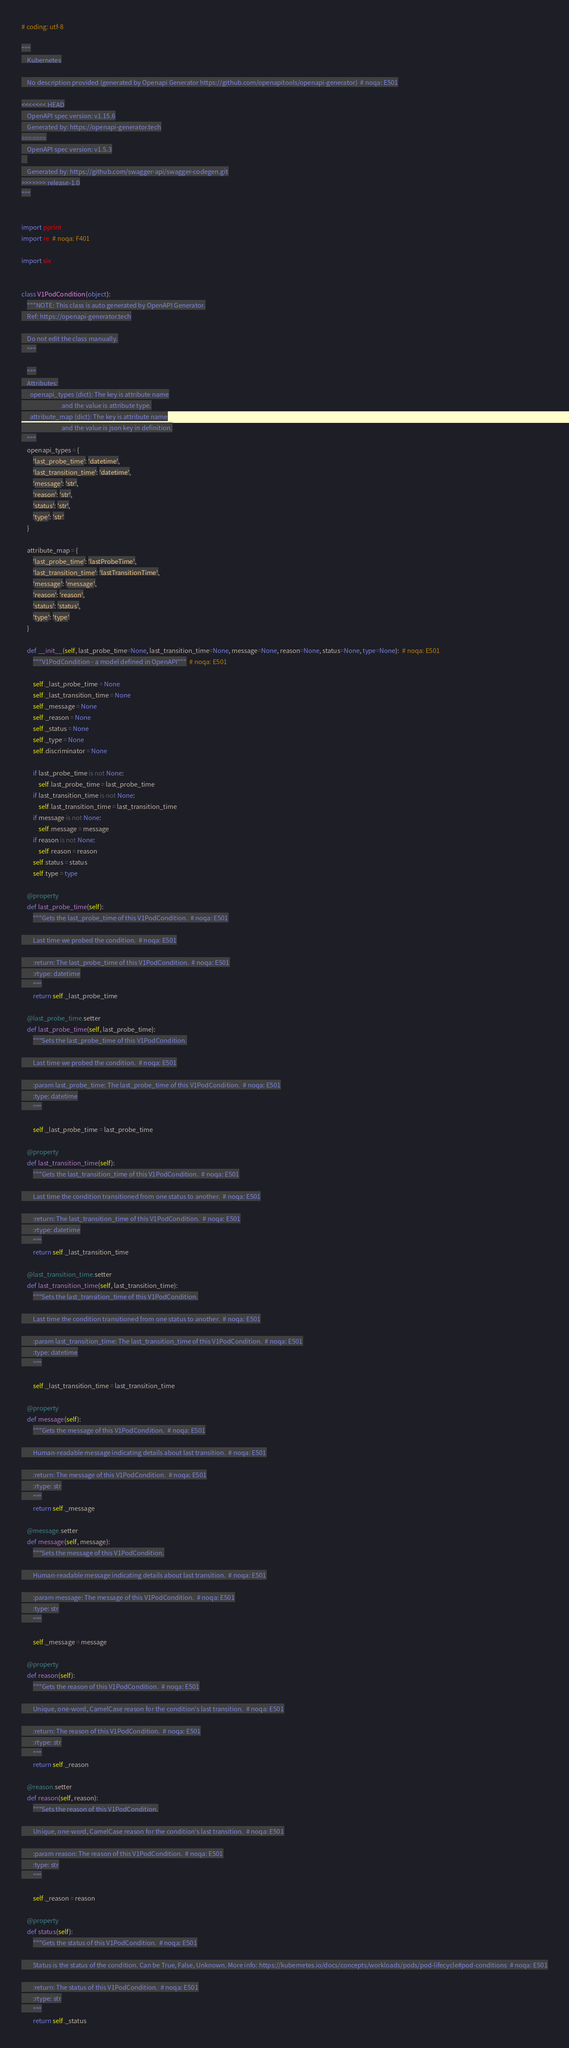<code> <loc_0><loc_0><loc_500><loc_500><_Python_># coding: utf-8

"""
    Kubernetes

    No description provided (generated by Openapi Generator https://github.com/openapitools/openapi-generator)  # noqa: E501

<<<<<<< HEAD
    OpenAPI spec version: v1.15.6
    Generated by: https://openapi-generator.tech
=======
    OpenAPI spec version: v1.5.3
    
    Generated by: https://github.com/swagger-api/swagger-codegen.git
>>>>>>> release-1.0
"""


import pprint
import re  # noqa: F401

import six


class V1PodCondition(object):
    """NOTE: This class is auto generated by OpenAPI Generator.
    Ref: https://openapi-generator.tech

    Do not edit the class manually.
    """

    """
    Attributes:
      openapi_types (dict): The key is attribute name
                            and the value is attribute type.
      attribute_map (dict): The key is attribute name
                            and the value is json key in definition.
    """
    openapi_types = {
        'last_probe_time': 'datetime',
        'last_transition_time': 'datetime',
        'message': 'str',
        'reason': 'str',
        'status': 'str',
        'type': 'str'
    }

    attribute_map = {
        'last_probe_time': 'lastProbeTime',
        'last_transition_time': 'lastTransitionTime',
        'message': 'message',
        'reason': 'reason',
        'status': 'status',
        'type': 'type'
    }

    def __init__(self, last_probe_time=None, last_transition_time=None, message=None, reason=None, status=None, type=None):  # noqa: E501
        """V1PodCondition - a model defined in OpenAPI"""  # noqa: E501

        self._last_probe_time = None
        self._last_transition_time = None
        self._message = None
        self._reason = None
        self._status = None
        self._type = None
        self.discriminator = None

        if last_probe_time is not None:
            self.last_probe_time = last_probe_time
        if last_transition_time is not None:
            self.last_transition_time = last_transition_time
        if message is not None:
            self.message = message
        if reason is not None:
            self.reason = reason
        self.status = status
        self.type = type

    @property
    def last_probe_time(self):
        """Gets the last_probe_time of this V1PodCondition.  # noqa: E501

        Last time we probed the condition.  # noqa: E501

        :return: The last_probe_time of this V1PodCondition.  # noqa: E501
        :rtype: datetime
        """
        return self._last_probe_time

    @last_probe_time.setter
    def last_probe_time(self, last_probe_time):
        """Sets the last_probe_time of this V1PodCondition.

        Last time we probed the condition.  # noqa: E501

        :param last_probe_time: The last_probe_time of this V1PodCondition.  # noqa: E501
        :type: datetime
        """

        self._last_probe_time = last_probe_time

    @property
    def last_transition_time(self):
        """Gets the last_transition_time of this V1PodCondition.  # noqa: E501

        Last time the condition transitioned from one status to another.  # noqa: E501

        :return: The last_transition_time of this V1PodCondition.  # noqa: E501
        :rtype: datetime
        """
        return self._last_transition_time

    @last_transition_time.setter
    def last_transition_time(self, last_transition_time):
        """Sets the last_transition_time of this V1PodCondition.

        Last time the condition transitioned from one status to another.  # noqa: E501

        :param last_transition_time: The last_transition_time of this V1PodCondition.  # noqa: E501
        :type: datetime
        """

        self._last_transition_time = last_transition_time

    @property
    def message(self):
        """Gets the message of this V1PodCondition.  # noqa: E501

        Human-readable message indicating details about last transition.  # noqa: E501

        :return: The message of this V1PodCondition.  # noqa: E501
        :rtype: str
        """
        return self._message

    @message.setter
    def message(self, message):
        """Sets the message of this V1PodCondition.

        Human-readable message indicating details about last transition.  # noqa: E501

        :param message: The message of this V1PodCondition.  # noqa: E501
        :type: str
        """

        self._message = message

    @property
    def reason(self):
        """Gets the reason of this V1PodCondition.  # noqa: E501

        Unique, one-word, CamelCase reason for the condition's last transition.  # noqa: E501

        :return: The reason of this V1PodCondition.  # noqa: E501
        :rtype: str
        """
        return self._reason

    @reason.setter
    def reason(self, reason):
        """Sets the reason of this V1PodCondition.

        Unique, one-word, CamelCase reason for the condition's last transition.  # noqa: E501

        :param reason: The reason of this V1PodCondition.  # noqa: E501
        :type: str
        """

        self._reason = reason

    @property
    def status(self):
        """Gets the status of this V1PodCondition.  # noqa: E501

        Status is the status of the condition. Can be True, False, Unknown. More info: https://kubernetes.io/docs/concepts/workloads/pods/pod-lifecycle#pod-conditions  # noqa: E501

        :return: The status of this V1PodCondition.  # noqa: E501
        :rtype: str
        """
        return self._status
</code> 